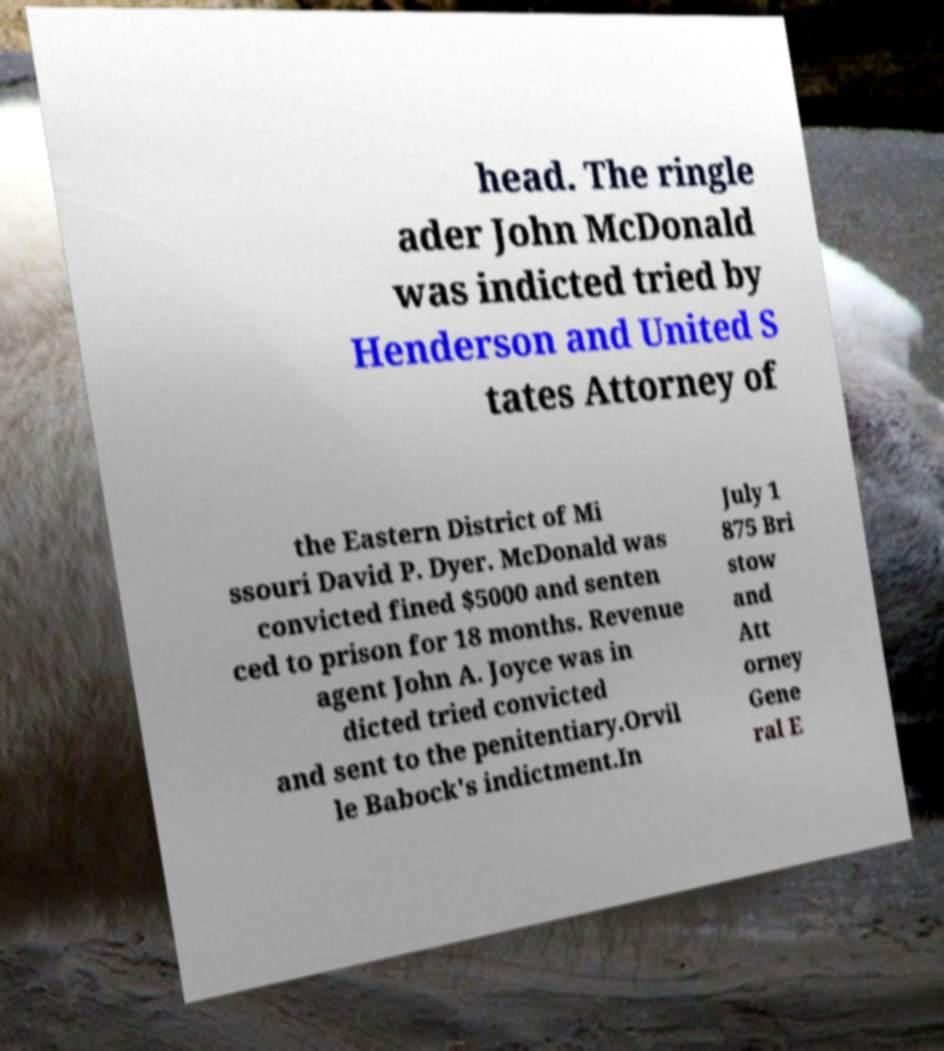Could you assist in decoding the text presented in this image and type it out clearly? head. The ringle ader John McDonald was indicted tried by Henderson and United S tates Attorney of the Eastern District of Mi ssouri David P. Dyer. McDonald was convicted fined $5000 and senten ced to prison for 18 months. Revenue agent John A. Joyce was in dicted tried convicted and sent to the penitentiary.Orvil le Babock's indictment.In July 1 875 Bri stow and Att orney Gene ral E 